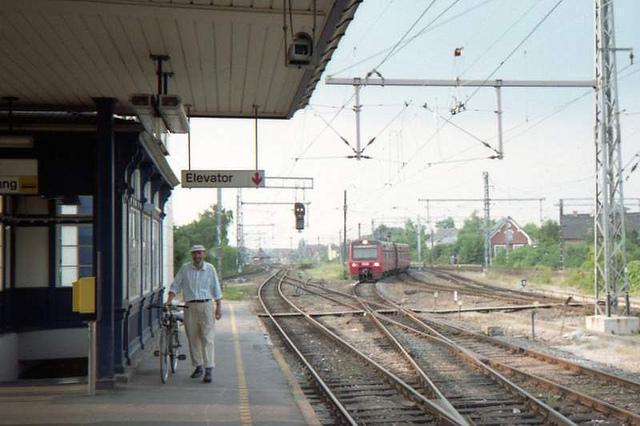What is the object hanging underneath the roof eave?
Select the accurate response from the four choices given to answer the question.
Options: Signal light, flood light, camera, speaker. Camera. 